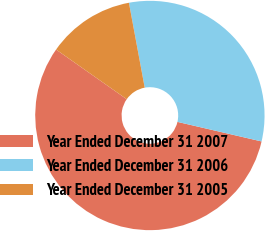Convert chart. <chart><loc_0><loc_0><loc_500><loc_500><pie_chart><fcel>Year Ended December 31 2007<fcel>Year Ended December 31 2006<fcel>Year Ended December 31 2005<nl><fcel>56.11%<fcel>31.56%<fcel>12.32%<nl></chart> 